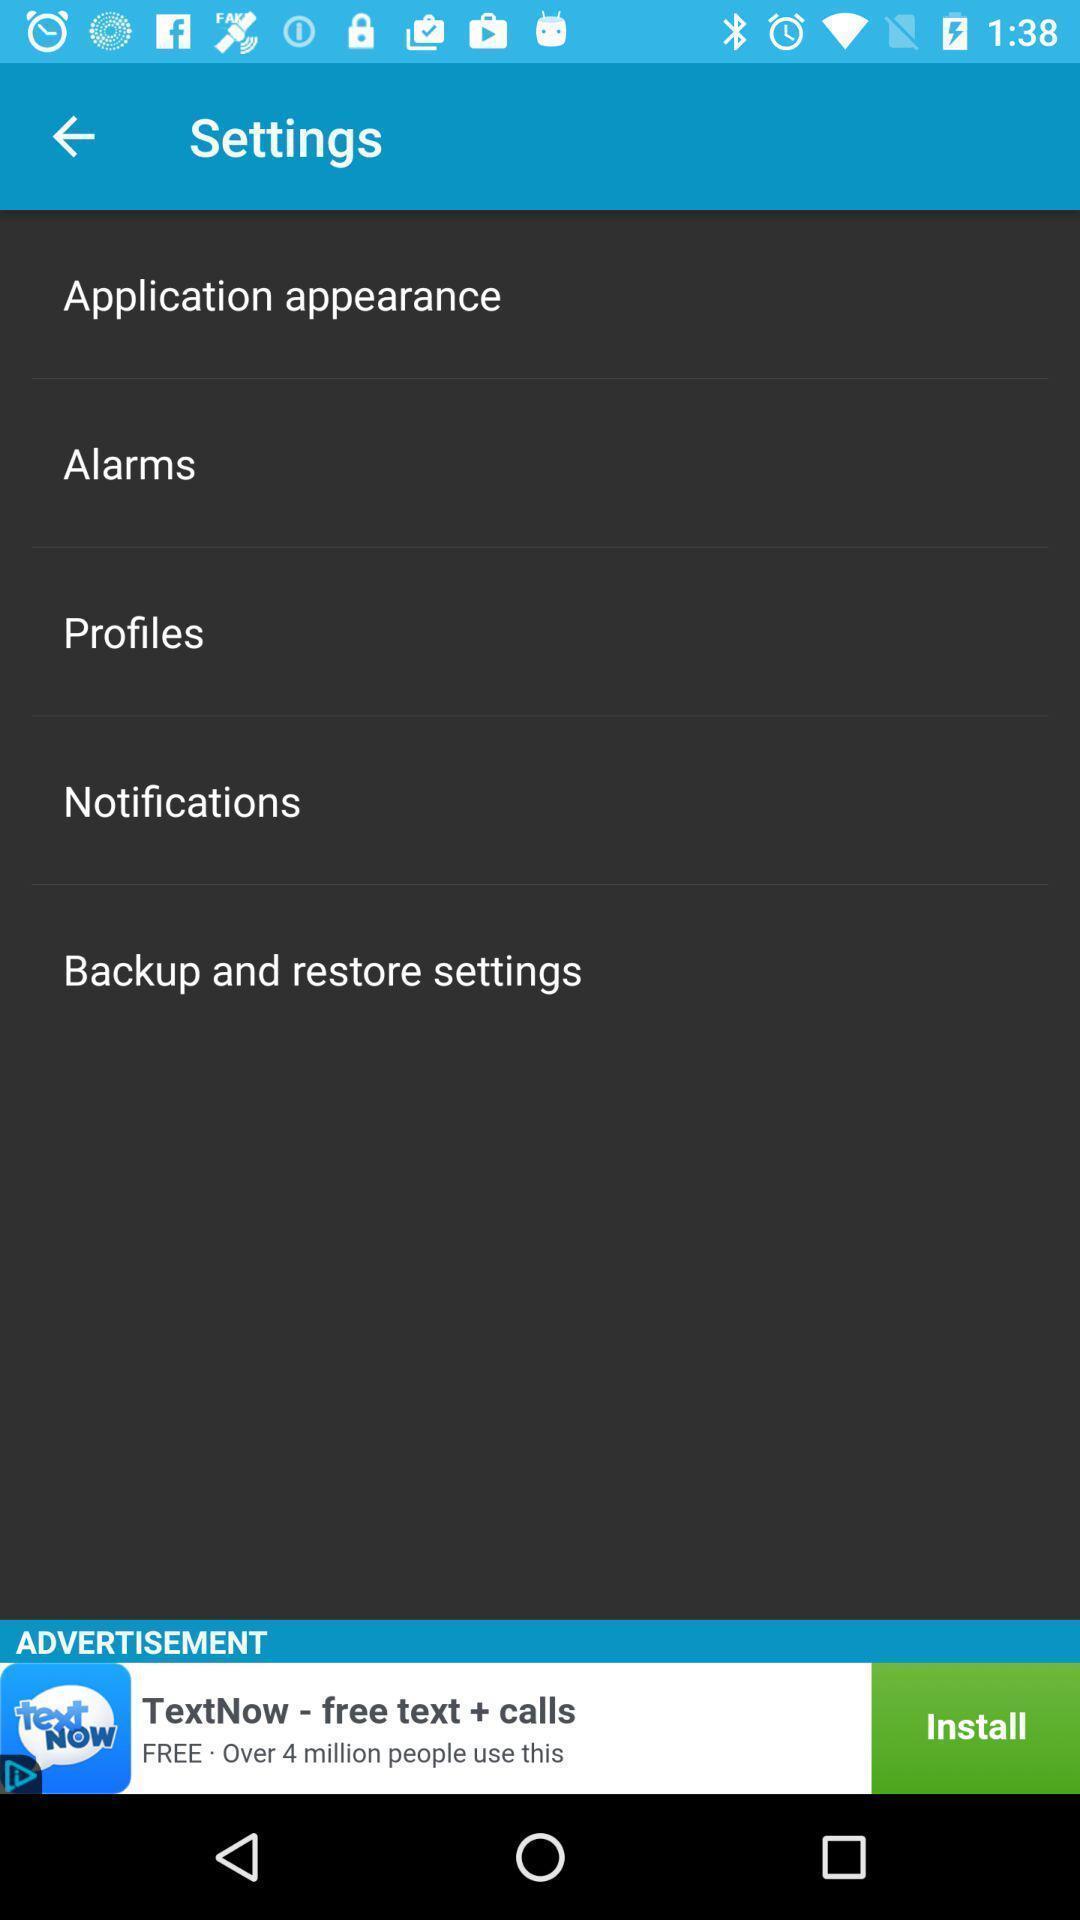Summarize the main components in this picture. Setting page displaying various options. 